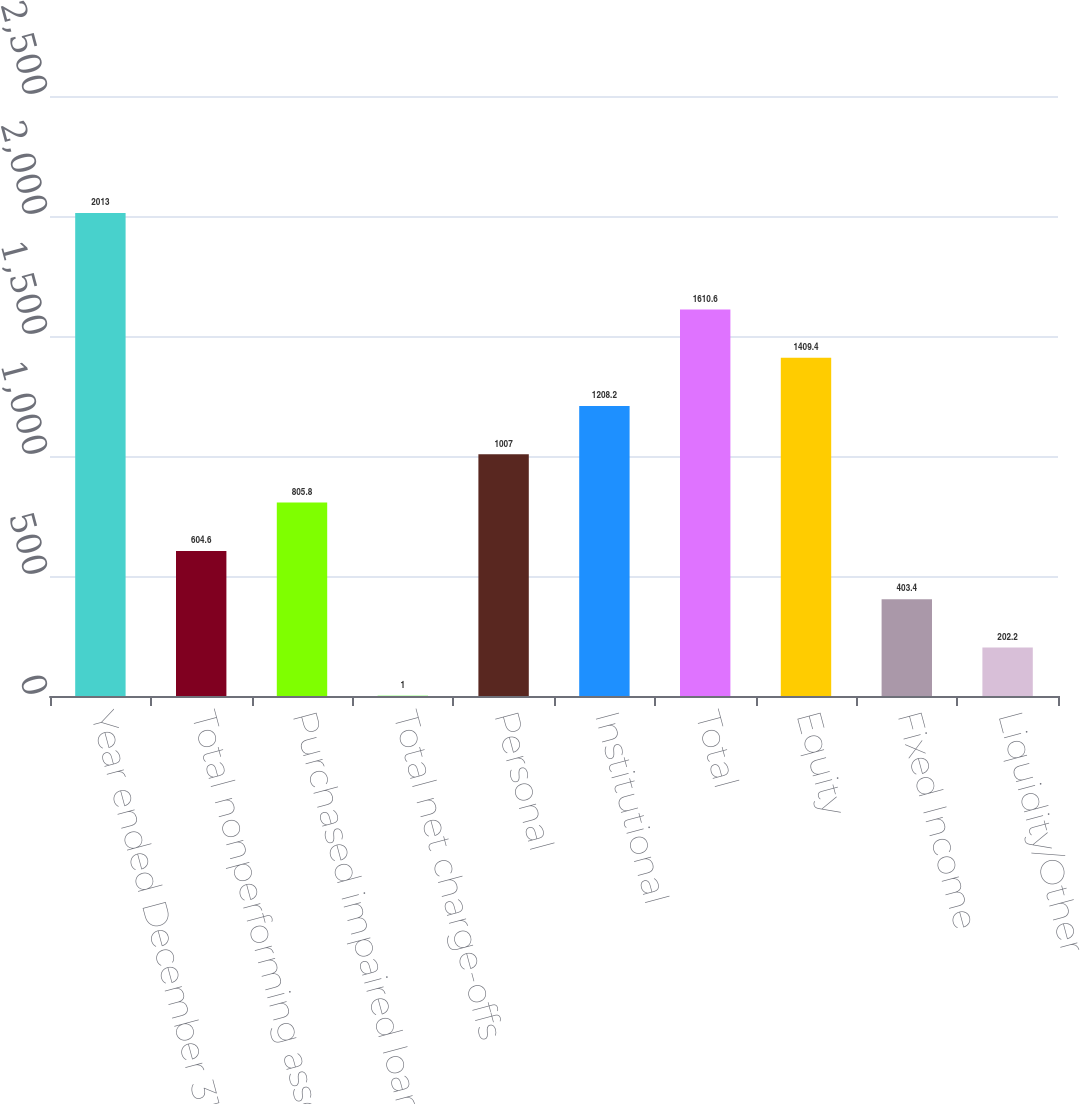<chart> <loc_0><loc_0><loc_500><loc_500><bar_chart><fcel>Year ended December 31 Dollars<fcel>Total nonperforming assets (a)<fcel>Purchased impaired loans (a)<fcel>Total net charge-offs<fcel>Personal<fcel>Institutional<fcel>Total<fcel>Equity<fcel>Fixed Income<fcel>Liquidity/Other<nl><fcel>2013<fcel>604.6<fcel>805.8<fcel>1<fcel>1007<fcel>1208.2<fcel>1610.6<fcel>1409.4<fcel>403.4<fcel>202.2<nl></chart> 